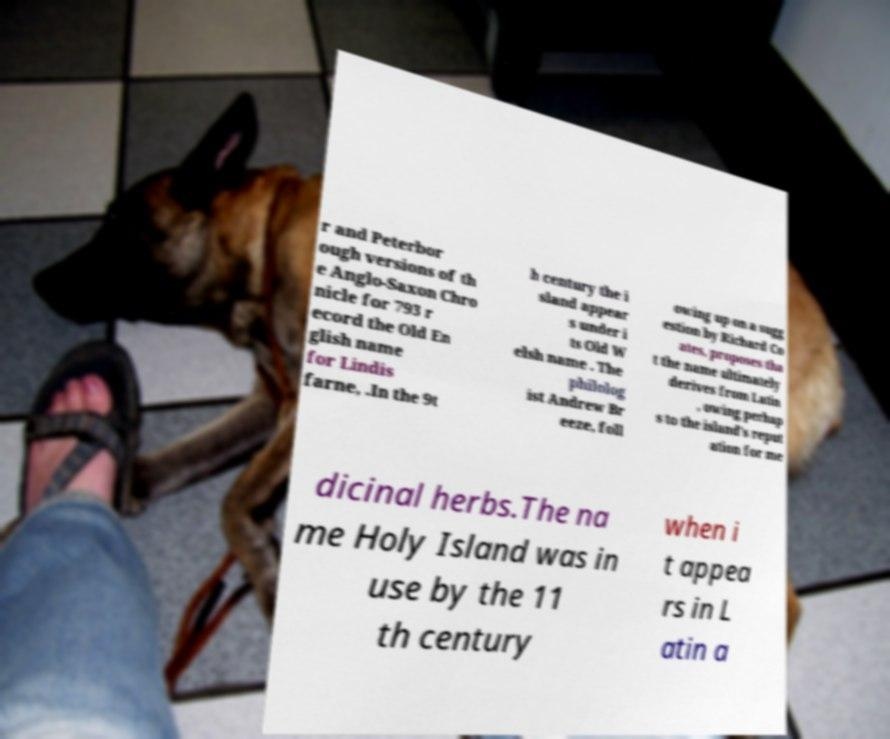Please read and relay the text visible in this image. What does it say? r and Peterbor ough versions of th e Anglo-Saxon Chro nicle for 793 r ecord the Old En glish name for Lindis farne, .In the 9t h century the i sland appear s under i ts Old W elsh name . The philolog ist Andrew Br eeze, foll owing up on a sugg estion by Richard Co ates, proposes tha t the name ultimately derives from Latin , owing perhap s to the island's reput ation for me dicinal herbs.The na me Holy Island was in use by the 11 th century when i t appea rs in L atin a 